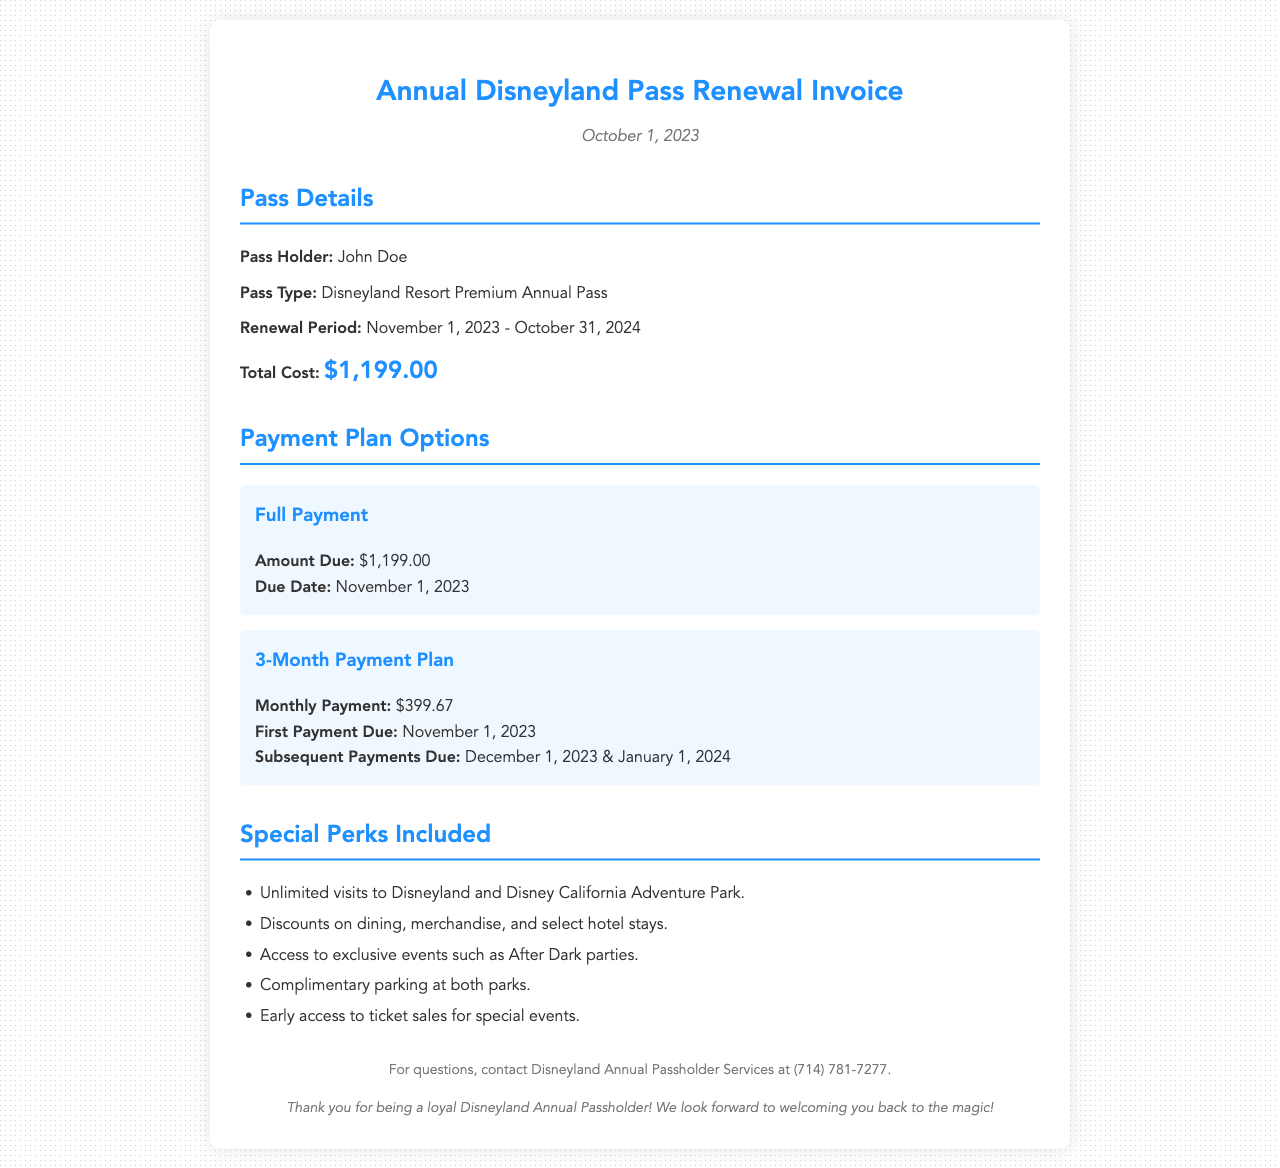What is the Pass Holder's name? The name of the Pass Holder is clearly stated in the invoice under "Pass Holder".
Answer: John Doe What is the total cost of the annual pass renewal? The total cost is listed in the "Total Cost" section of the invoice.
Answer: $1,199.00 What is the renewal period for the pass? The renewal period is specified under "Renewal Period" in the details section.
Answer: November 1, 2023 - October 31, 2024 How much is the monthly payment for the 3-month payment plan? The monthly payment amount is provided in the "3-Month Payment Plan" section.
Answer: $399.67 When is the first payment due for the full payment option? The due date for the full payment is mentioned in the payment plan options.
Answer: November 1, 2023 What special perk includes unlimited visits? This perk refers to the access provided with the pass and is mentioned in the "Special Perks Included" section.
Answer: Unlimited visits to Disneyland and Disney California Adventure Park How many payments are made in the 3-month plan? The structure of the payment plan indicates the total number of payments across the plan duration.
Answer: 3 payments What discount perks are included with the pass? The discounts on various services are listed under the "Special Perks Included" section.
Answer: Discounts on dining, merchandise, and select hotel stays Which service should be contacted for questions regarding the invoice? Contact information is provided for inquiries in the footer of the invoice.
Answer: Disneyland Annual Passholder Services at (714) 781-7277 